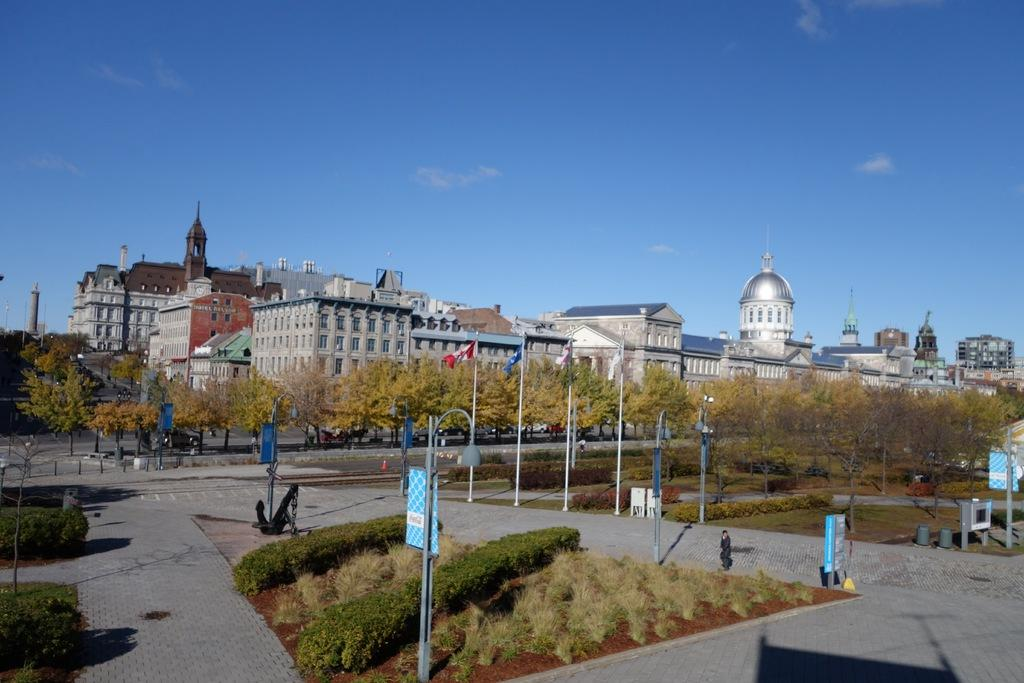What type of structures can be seen in the image? There are buildings in the image. What natural elements are present in the image? There are trees and plants in the image. Can you describe the people in the image? There are people in the image. What are the boards attached to in the image? The boards are attached to poles in the image. What else can be seen in the image besides the mentioned elements? There are other objects in the image. What is visible in the background of the image? The sky is visible in the background of the image. What type of bottle can be seen being polished by the people in the image? There is no bottle present in the image, nor is there any indication of polishing. 